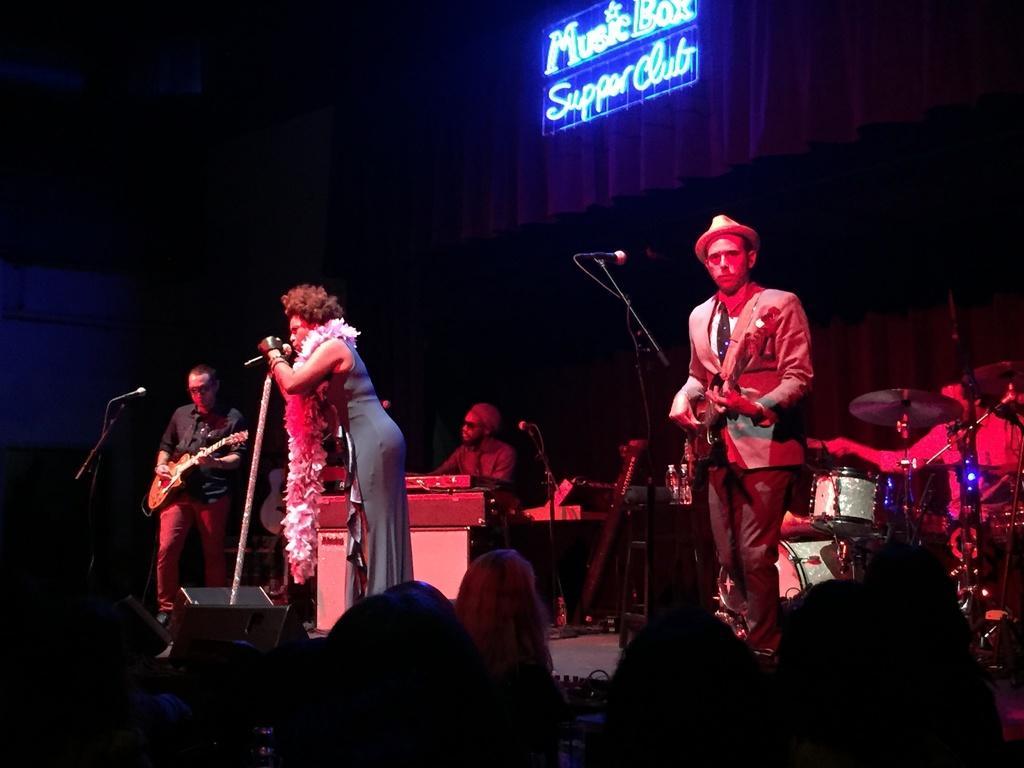Please provide a concise description of this image. there is a music band on the stage. Two of them are playing guitars. One of the lady is singing, holding a microphone in front of her. In the background there is a guy playing a piano. Right side there is a guy playing drums. And the audience are enjoying their concert. In the background there is a curtain and some lights here. 